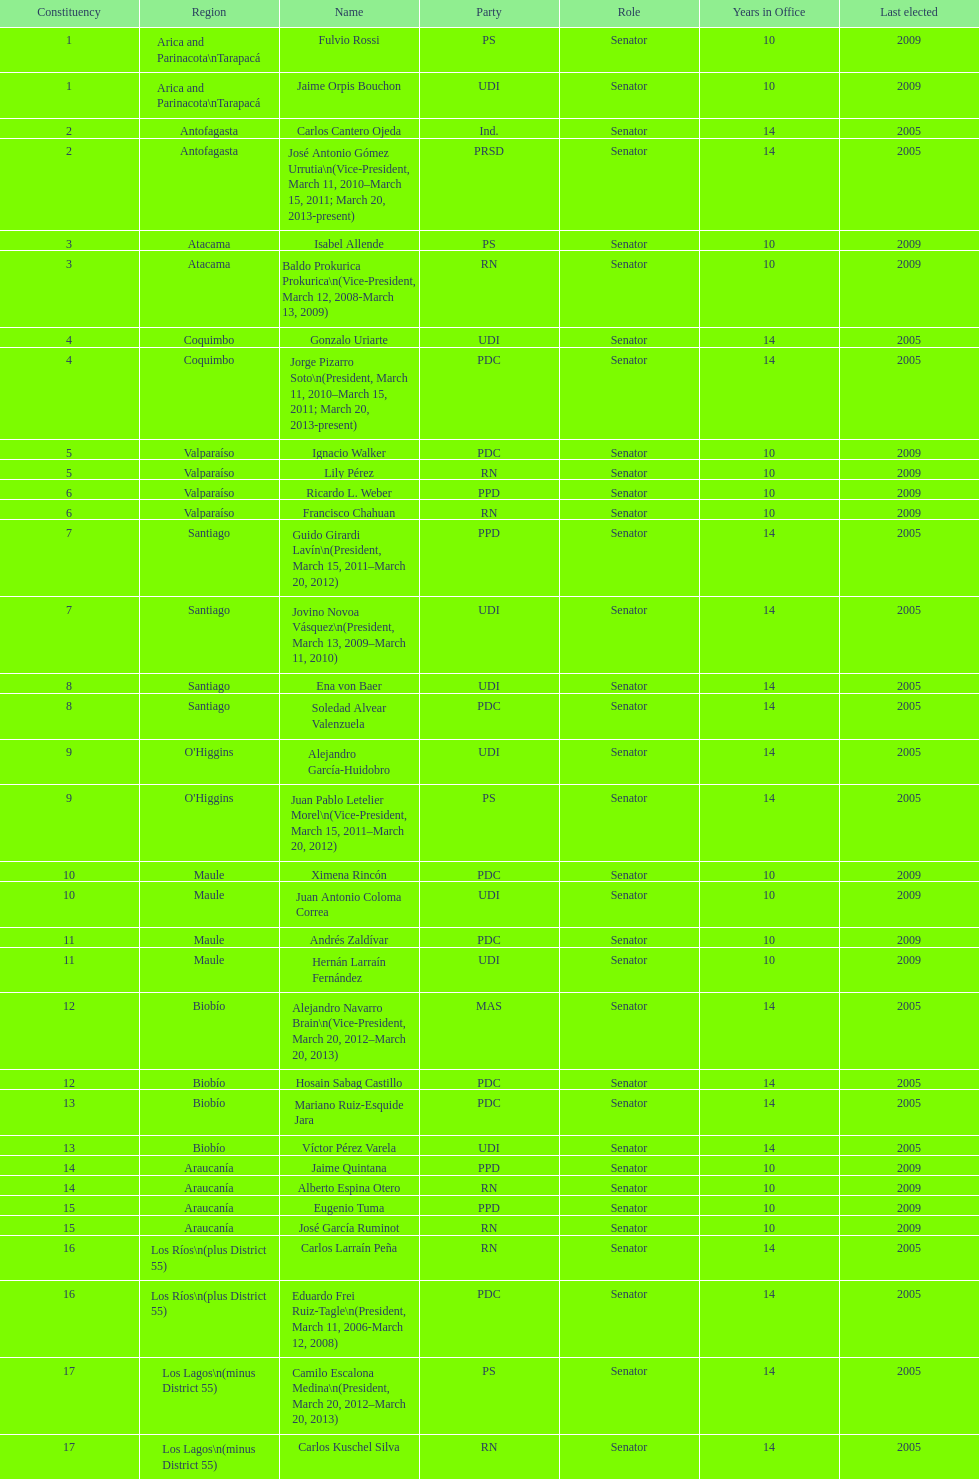What is the difference in years between constiuency 1 and 2? 4 years. 